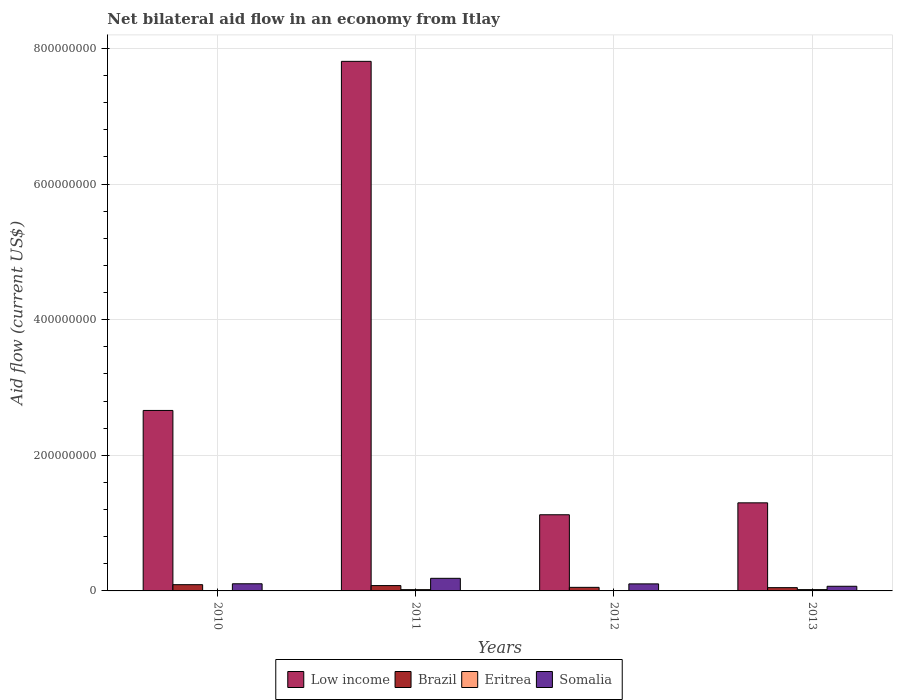Are the number of bars per tick equal to the number of legend labels?
Keep it short and to the point. Yes. Are the number of bars on each tick of the X-axis equal?
Keep it short and to the point. Yes. What is the label of the 3rd group of bars from the left?
Provide a succinct answer. 2012. What is the net bilateral aid flow in Brazil in 2011?
Offer a very short reply. 7.86e+06. Across all years, what is the maximum net bilateral aid flow in Brazil?
Your response must be concise. 9.20e+06. Across all years, what is the minimum net bilateral aid flow in Low income?
Ensure brevity in your answer.  1.12e+08. What is the total net bilateral aid flow in Eritrea in the graph?
Keep it short and to the point. 4.52e+06. What is the difference between the net bilateral aid flow in Eritrea in 2010 and that in 2013?
Ensure brevity in your answer.  -1.79e+06. What is the difference between the net bilateral aid flow in Somalia in 2010 and the net bilateral aid flow in Low income in 2013?
Offer a very short reply. -1.19e+08. What is the average net bilateral aid flow in Somalia per year?
Offer a very short reply. 1.16e+07. In the year 2010, what is the difference between the net bilateral aid flow in Somalia and net bilateral aid flow in Low income?
Provide a succinct answer. -2.56e+08. What is the ratio of the net bilateral aid flow in Brazil in 2011 to that in 2012?
Your answer should be very brief. 1.49. Is the net bilateral aid flow in Somalia in 2010 less than that in 2012?
Your response must be concise. No. Is the difference between the net bilateral aid flow in Somalia in 2010 and 2013 greater than the difference between the net bilateral aid flow in Low income in 2010 and 2013?
Your answer should be very brief. No. What is the difference between the highest and the second highest net bilateral aid flow in Eritrea?
Your answer should be very brief. 4.00e+04. What is the difference between the highest and the lowest net bilateral aid flow in Eritrea?
Give a very brief answer. 1.79e+06. In how many years, is the net bilateral aid flow in Eritrea greater than the average net bilateral aid flow in Eritrea taken over all years?
Give a very brief answer. 2. What does the 3rd bar from the left in 2013 represents?
Your answer should be very brief. Eritrea. What does the 1st bar from the right in 2011 represents?
Offer a terse response. Somalia. Is it the case that in every year, the sum of the net bilateral aid flow in Somalia and net bilateral aid flow in Low income is greater than the net bilateral aid flow in Brazil?
Your answer should be very brief. Yes. How many bars are there?
Your response must be concise. 16. How many years are there in the graph?
Make the answer very short. 4. Does the graph contain any zero values?
Provide a succinct answer. No. Does the graph contain grids?
Keep it short and to the point. Yes. Where does the legend appear in the graph?
Ensure brevity in your answer.  Bottom center. How many legend labels are there?
Ensure brevity in your answer.  4. How are the legend labels stacked?
Make the answer very short. Horizontal. What is the title of the graph?
Your answer should be very brief. Net bilateral aid flow in an economy from Itlay. What is the label or title of the Y-axis?
Offer a terse response. Aid flow (current US$). What is the Aid flow (current US$) of Low income in 2010?
Give a very brief answer. 2.66e+08. What is the Aid flow (current US$) in Brazil in 2010?
Your answer should be compact. 9.20e+06. What is the Aid flow (current US$) in Eritrea in 2010?
Offer a terse response. 1.50e+05. What is the Aid flow (current US$) in Somalia in 2010?
Make the answer very short. 1.05e+07. What is the Aid flow (current US$) of Low income in 2011?
Offer a very short reply. 7.81e+08. What is the Aid flow (current US$) of Brazil in 2011?
Ensure brevity in your answer.  7.86e+06. What is the Aid flow (current US$) of Eritrea in 2011?
Keep it short and to the point. 1.90e+06. What is the Aid flow (current US$) in Somalia in 2011?
Give a very brief answer. 1.86e+07. What is the Aid flow (current US$) in Low income in 2012?
Keep it short and to the point. 1.12e+08. What is the Aid flow (current US$) of Brazil in 2012?
Your response must be concise. 5.26e+06. What is the Aid flow (current US$) in Eritrea in 2012?
Make the answer very short. 5.30e+05. What is the Aid flow (current US$) of Somalia in 2012?
Offer a very short reply. 1.04e+07. What is the Aid flow (current US$) of Low income in 2013?
Your response must be concise. 1.30e+08. What is the Aid flow (current US$) in Brazil in 2013?
Make the answer very short. 4.82e+06. What is the Aid flow (current US$) of Eritrea in 2013?
Your answer should be very brief. 1.94e+06. What is the Aid flow (current US$) of Somalia in 2013?
Your response must be concise. 6.85e+06. Across all years, what is the maximum Aid flow (current US$) in Low income?
Your response must be concise. 7.81e+08. Across all years, what is the maximum Aid flow (current US$) in Brazil?
Provide a succinct answer. 9.20e+06. Across all years, what is the maximum Aid flow (current US$) in Eritrea?
Your answer should be compact. 1.94e+06. Across all years, what is the maximum Aid flow (current US$) of Somalia?
Your answer should be very brief. 1.86e+07. Across all years, what is the minimum Aid flow (current US$) of Low income?
Provide a succinct answer. 1.12e+08. Across all years, what is the minimum Aid flow (current US$) in Brazil?
Keep it short and to the point. 4.82e+06. Across all years, what is the minimum Aid flow (current US$) in Eritrea?
Keep it short and to the point. 1.50e+05. Across all years, what is the minimum Aid flow (current US$) of Somalia?
Your answer should be compact. 6.85e+06. What is the total Aid flow (current US$) in Low income in the graph?
Make the answer very short. 1.29e+09. What is the total Aid flow (current US$) in Brazil in the graph?
Give a very brief answer. 2.71e+07. What is the total Aid flow (current US$) in Eritrea in the graph?
Your answer should be compact. 4.52e+06. What is the total Aid flow (current US$) of Somalia in the graph?
Your answer should be very brief. 4.63e+07. What is the difference between the Aid flow (current US$) of Low income in 2010 and that in 2011?
Provide a succinct answer. -5.15e+08. What is the difference between the Aid flow (current US$) in Brazil in 2010 and that in 2011?
Make the answer very short. 1.34e+06. What is the difference between the Aid flow (current US$) in Eritrea in 2010 and that in 2011?
Your response must be concise. -1.75e+06. What is the difference between the Aid flow (current US$) in Somalia in 2010 and that in 2011?
Keep it short and to the point. -8.05e+06. What is the difference between the Aid flow (current US$) in Low income in 2010 and that in 2012?
Offer a very short reply. 1.54e+08. What is the difference between the Aid flow (current US$) in Brazil in 2010 and that in 2012?
Keep it short and to the point. 3.94e+06. What is the difference between the Aid flow (current US$) in Eritrea in 2010 and that in 2012?
Your answer should be compact. -3.80e+05. What is the difference between the Aid flow (current US$) of Somalia in 2010 and that in 2012?
Make the answer very short. 1.50e+05. What is the difference between the Aid flow (current US$) of Low income in 2010 and that in 2013?
Your answer should be very brief. 1.36e+08. What is the difference between the Aid flow (current US$) in Brazil in 2010 and that in 2013?
Offer a very short reply. 4.38e+06. What is the difference between the Aid flow (current US$) in Eritrea in 2010 and that in 2013?
Your answer should be compact. -1.79e+06. What is the difference between the Aid flow (current US$) in Somalia in 2010 and that in 2013?
Offer a very short reply. 3.68e+06. What is the difference between the Aid flow (current US$) of Low income in 2011 and that in 2012?
Your answer should be compact. 6.69e+08. What is the difference between the Aid flow (current US$) of Brazil in 2011 and that in 2012?
Your answer should be compact. 2.60e+06. What is the difference between the Aid flow (current US$) of Eritrea in 2011 and that in 2012?
Your answer should be compact. 1.37e+06. What is the difference between the Aid flow (current US$) in Somalia in 2011 and that in 2012?
Provide a succinct answer. 8.20e+06. What is the difference between the Aid flow (current US$) of Low income in 2011 and that in 2013?
Offer a terse response. 6.51e+08. What is the difference between the Aid flow (current US$) in Brazil in 2011 and that in 2013?
Ensure brevity in your answer.  3.04e+06. What is the difference between the Aid flow (current US$) in Somalia in 2011 and that in 2013?
Ensure brevity in your answer.  1.17e+07. What is the difference between the Aid flow (current US$) of Low income in 2012 and that in 2013?
Your response must be concise. -1.76e+07. What is the difference between the Aid flow (current US$) in Eritrea in 2012 and that in 2013?
Provide a short and direct response. -1.41e+06. What is the difference between the Aid flow (current US$) of Somalia in 2012 and that in 2013?
Your answer should be compact. 3.53e+06. What is the difference between the Aid flow (current US$) of Low income in 2010 and the Aid flow (current US$) of Brazil in 2011?
Offer a very short reply. 2.58e+08. What is the difference between the Aid flow (current US$) in Low income in 2010 and the Aid flow (current US$) in Eritrea in 2011?
Your answer should be compact. 2.64e+08. What is the difference between the Aid flow (current US$) of Low income in 2010 and the Aid flow (current US$) of Somalia in 2011?
Offer a terse response. 2.48e+08. What is the difference between the Aid flow (current US$) in Brazil in 2010 and the Aid flow (current US$) in Eritrea in 2011?
Offer a very short reply. 7.30e+06. What is the difference between the Aid flow (current US$) of Brazil in 2010 and the Aid flow (current US$) of Somalia in 2011?
Ensure brevity in your answer.  -9.38e+06. What is the difference between the Aid flow (current US$) in Eritrea in 2010 and the Aid flow (current US$) in Somalia in 2011?
Give a very brief answer. -1.84e+07. What is the difference between the Aid flow (current US$) of Low income in 2010 and the Aid flow (current US$) of Brazil in 2012?
Your answer should be very brief. 2.61e+08. What is the difference between the Aid flow (current US$) of Low income in 2010 and the Aid flow (current US$) of Eritrea in 2012?
Keep it short and to the point. 2.66e+08. What is the difference between the Aid flow (current US$) of Low income in 2010 and the Aid flow (current US$) of Somalia in 2012?
Make the answer very short. 2.56e+08. What is the difference between the Aid flow (current US$) in Brazil in 2010 and the Aid flow (current US$) in Eritrea in 2012?
Give a very brief answer. 8.67e+06. What is the difference between the Aid flow (current US$) of Brazil in 2010 and the Aid flow (current US$) of Somalia in 2012?
Provide a short and direct response. -1.18e+06. What is the difference between the Aid flow (current US$) of Eritrea in 2010 and the Aid flow (current US$) of Somalia in 2012?
Provide a short and direct response. -1.02e+07. What is the difference between the Aid flow (current US$) in Low income in 2010 and the Aid flow (current US$) in Brazil in 2013?
Provide a short and direct response. 2.61e+08. What is the difference between the Aid flow (current US$) of Low income in 2010 and the Aid flow (current US$) of Eritrea in 2013?
Keep it short and to the point. 2.64e+08. What is the difference between the Aid flow (current US$) of Low income in 2010 and the Aid flow (current US$) of Somalia in 2013?
Provide a short and direct response. 2.59e+08. What is the difference between the Aid flow (current US$) of Brazil in 2010 and the Aid flow (current US$) of Eritrea in 2013?
Your response must be concise. 7.26e+06. What is the difference between the Aid flow (current US$) in Brazil in 2010 and the Aid flow (current US$) in Somalia in 2013?
Your answer should be compact. 2.35e+06. What is the difference between the Aid flow (current US$) of Eritrea in 2010 and the Aid flow (current US$) of Somalia in 2013?
Provide a short and direct response. -6.70e+06. What is the difference between the Aid flow (current US$) of Low income in 2011 and the Aid flow (current US$) of Brazil in 2012?
Provide a short and direct response. 7.76e+08. What is the difference between the Aid flow (current US$) in Low income in 2011 and the Aid flow (current US$) in Eritrea in 2012?
Give a very brief answer. 7.80e+08. What is the difference between the Aid flow (current US$) of Low income in 2011 and the Aid flow (current US$) of Somalia in 2012?
Make the answer very short. 7.71e+08. What is the difference between the Aid flow (current US$) of Brazil in 2011 and the Aid flow (current US$) of Eritrea in 2012?
Your response must be concise. 7.33e+06. What is the difference between the Aid flow (current US$) in Brazil in 2011 and the Aid flow (current US$) in Somalia in 2012?
Keep it short and to the point. -2.52e+06. What is the difference between the Aid flow (current US$) of Eritrea in 2011 and the Aid flow (current US$) of Somalia in 2012?
Offer a very short reply. -8.48e+06. What is the difference between the Aid flow (current US$) in Low income in 2011 and the Aid flow (current US$) in Brazil in 2013?
Your answer should be compact. 7.76e+08. What is the difference between the Aid flow (current US$) of Low income in 2011 and the Aid flow (current US$) of Eritrea in 2013?
Your answer should be very brief. 7.79e+08. What is the difference between the Aid flow (current US$) of Low income in 2011 and the Aid flow (current US$) of Somalia in 2013?
Make the answer very short. 7.74e+08. What is the difference between the Aid flow (current US$) of Brazil in 2011 and the Aid flow (current US$) of Eritrea in 2013?
Keep it short and to the point. 5.92e+06. What is the difference between the Aid flow (current US$) in Brazil in 2011 and the Aid flow (current US$) in Somalia in 2013?
Provide a short and direct response. 1.01e+06. What is the difference between the Aid flow (current US$) of Eritrea in 2011 and the Aid flow (current US$) of Somalia in 2013?
Ensure brevity in your answer.  -4.95e+06. What is the difference between the Aid flow (current US$) in Low income in 2012 and the Aid flow (current US$) in Brazil in 2013?
Make the answer very short. 1.07e+08. What is the difference between the Aid flow (current US$) in Low income in 2012 and the Aid flow (current US$) in Eritrea in 2013?
Give a very brief answer. 1.10e+08. What is the difference between the Aid flow (current US$) in Low income in 2012 and the Aid flow (current US$) in Somalia in 2013?
Provide a succinct answer. 1.05e+08. What is the difference between the Aid flow (current US$) of Brazil in 2012 and the Aid flow (current US$) of Eritrea in 2013?
Your answer should be compact. 3.32e+06. What is the difference between the Aid flow (current US$) of Brazil in 2012 and the Aid flow (current US$) of Somalia in 2013?
Give a very brief answer. -1.59e+06. What is the difference between the Aid flow (current US$) in Eritrea in 2012 and the Aid flow (current US$) in Somalia in 2013?
Keep it short and to the point. -6.32e+06. What is the average Aid flow (current US$) of Low income per year?
Provide a succinct answer. 3.22e+08. What is the average Aid flow (current US$) in Brazil per year?
Keep it short and to the point. 6.78e+06. What is the average Aid flow (current US$) of Eritrea per year?
Your answer should be very brief. 1.13e+06. What is the average Aid flow (current US$) of Somalia per year?
Ensure brevity in your answer.  1.16e+07. In the year 2010, what is the difference between the Aid flow (current US$) in Low income and Aid flow (current US$) in Brazil?
Offer a terse response. 2.57e+08. In the year 2010, what is the difference between the Aid flow (current US$) in Low income and Aid flow (current US$) in Eritrea?
Ensure brevity in your answer.  2.66e+08. In the year 2010, what is the difference between the Aid flow (current US$) in Low income and Aid flow (current US$) in Somalia?
Ensure brevity in your answer.  2.56e+08. In the year 2010, what is the difference between the Aid flow (current US$) in Brazil and Aid flow (current US$) in Eritrea?
Your response must be concise. 9.05e+06. In the year 2010, what is the difference between the Aid flow (current US$) of Brazil and Aid flow (current US$) of Somalia?
Your response must be concise. -1.33e+06. In the year 2010, what is the difference between the Aid flow (current US$) of Eritrea and Aid flow (current US$) of Somalia?
Your response must be concise. -1.04e+07. In the year 2011, what is the difference between the Aid flow (current US$) in Low income and Aid flow (current US$) in Brazil?
Make the answer very short. 7.73e+08. In the year 2011, what is the difference between the Aid flow (current US$) in Low income and Aid flow (current US$) in Eritrea?
Your answer should be very brief. 7.79e+08. In the year 2011, what is the difference between the Aid flow (current US$) of Low income and Aid flow (current US$) of Somalia?
Offer a terse response. 7.62e+08. In the year 2011, what is the difference between the Aid flow (current US$) of Brazil and Aid flow (current US$) of Eritrea?
Your answer should be compact. 5.96e+06. In the year 2011, what is the difference between the Aid flow (current US$) in Brazil and Aid flow (current US$) in Somalia?
Provide a succinct answer. -1.07e+07. In the year 2011, what is the difference between the Aid flow (current US$) of Eritrea and Aid flow (current US$) of Somalia?
Your response must be concise. -1.67e+07. In the year 2012, what is the difference between the Aid flow (current US$) of Low income and Aid flow (current US$) of Brazil?
Offer a terse response. 1.07e+08. In the year 2012, what is the difference between the Aid flow (current US$) in Low income and Aid flow (current US$) in Eritrea?
Offer a terse response. 1.12e+08. In the year 2012, what is the difference between the Aid flow (current US$) of Low income and Aid flow (current US$) of Somalia?
Your answer should be very brief. 1.02e+08. In the year 2012, what is the difference between the Aid flow (current US$) in Brazil and Aid flow (current US$) in Eritrea?
Ensure brevity in your answer.  4.73e+06. In the year 2012, what is the difference between the Aid flow (current US$) of Brazil and Aid flow (current US$) of Somalia?
Your response must be concise. -5.12e+06. In the year 2012, what is the difference between the Aid flow (current US$) in Eritrea and Aid flow (current US$) in Somalia?
Offer a very short reply. -9.85e+06. In the year 2013, what is the difference between the Aid flow (current US$) of Low income and Aid flow (current US$) of Brazil?
Your answer should be compact. 1.25e+08. In the year 2013, what is the difference between the Aid flow (current US$) of Low income and Aid flow (current US$) of Eritrea?
Provide a succinct answer. 1.28e+08. In the year 2013, what is the difference between the Aid flow (current US$) of Low income and Aid flow (current US$) of Somalia?
Your answer should be very brief. 1.23e+08. In the year 2013, what is the difference between the Aid flow (current US$) of Brazil and Aid flow (current US$) of Eritrea?
Give a very brief answer. 2.88e+06. In the year 2013, what is the difference between the Aid flow (current US$) in Brazil and Aid flow (current US$) in Somalia?
Your answer should be very brief. -2.03e+06. In the year 2013, what is the difference between the Aid flow (current US$) in Eritrea and Aid flow (current US$) in Somalia?
Offer a very short reply. -4.91e+06. What is the ratio of the Aid flow (current US$) of Low income in 2010 to that in 2011?
Your answer should be very brief. 0.34. What is the ratio of the Aid flow (current US$) in Brazil in 2010 to that in 2011?
Offer a very short reply. 1.17. What is the ratio of the Aid flow (current US$) in Eritrea in 2010 to that in 2011?
Ensure brevity in your answer.  0.08. What is the ratio of the Aid flow (current US$) in Somalia in 2010 to that in 2011?
Give a very brief answer. 0.57. What is the ratio of the Aid flow (current US$) in Low income in 2010 to that in 2012?
Offer a very short reply. 2.37. What is the ratio of the Aid flow (current US$) of Brazil in 2010 to that in 2012?
Your answer should be very brief. 1.75. What is the ratio of the Aid flow (current US$) of Eritrea in 2010 to that in 2012?
Offer a very short reply. 0.28. What is the ratio of the Aid flow (current US$) in Somalia in 2010 to that in 2012?
Your response must be concise. 1.01. What is the ratio of the Aid flow (current US$) of Low income in 2010 to that in 2013?
Your response must be concise. 2.05. What is the ratio of the Aid flow (current US$) of Brazil in 2010 to that in 2013?
Offer a very short reply. 1.91. What is the ratio of the Aid flow (current US$) in Eritrea in 2010 to that in 2013?
Provide a succinct answer. 0.08. What is the ratio of the Aid flow (current US$) of Somalia in 2010 to that in 2013?
Give a very brief answer. 1.54. What is the ratio of the Aid flow (current US$) in Low income in 2011 to that in 2012?
Your answer should be very brief. 6.95. What is the ratio of the Aid flow (current US$) in Brazil in 2011 to that in 2012?
Your answer should be compact. 1.49. What is the ratio of the Aid flow (current US$) in Eritrea in 2011 to that in 2012?
Offer a terse response. 3.58. What is the ratio of the Aid flow (current US$) in Somalia in 2011 to that in 2012?
Ensure brevity in your answer.  1.79. What is the ratio of the Aid flow (current US$) in Low income in 2011 to that in 2013?
Give a very brief answer. 6.01. What is the ratio of the Aid flow (current US$) in Brazil in 2011 to that in 2013?
Offer a very short reply. 1.63. What is the ratio of the Aid flow (current US$) in Eritrea in 2011 to that in 2013?
Your answer should be very brief. 0.98. What is the ratio of the Aid flow (current US$) in Somalia in 2011 to that in 2013?
Ensure brevity in your answer.  2.71. What is the ratio of the Aid flow (current US$) in Low income in 2012 to that in 2013?
Offer a terse response. 0.86. What is the ratio of the Aid flow (current US$) in Brazil in 2012 to that in 2013?
Your answer should be very brief. 1.09. What is the ratio of the Aid flow (current US$) in Eritrea in 2012 to that in 2013?
Give a very brief answer. 0.27. What is the ratio of the Aid flow (current US$) in Somalia in 2012 to that in 2013?
Keep it short and to the point. 1.52. What is the difference between the highest and the second highest Aid flow (current US$) in Low income?
Your response must be concise. 5.15e+08. What is the difference between the highest and the second highest Aid flow (current US$) of Brazil?
Your answer should be compact. 1.34e+06. What is the difference between the highest and the second highest Aid flow (current US$) in Somalia?
Provide a short and direct response. 8.05e+06. What is the difference between the highest and the lowest Aid flow (current US$) in Low income?
Provide a short and direct response. 6.69e+08. What is the difference between the highest and the lowest Aid flow (current US$) in Brazil?
Provide a succinct answer. 4.38e+06. What is the difference between the highest and the lowest Aid flow (current US$) in Eritrea?
Keep it short and to the point. 1.79e+06. What is the difference between the highest and the lowest Aid flow (current US$) of Somalia?
Provide a short and direct response. 1.17e+07. 